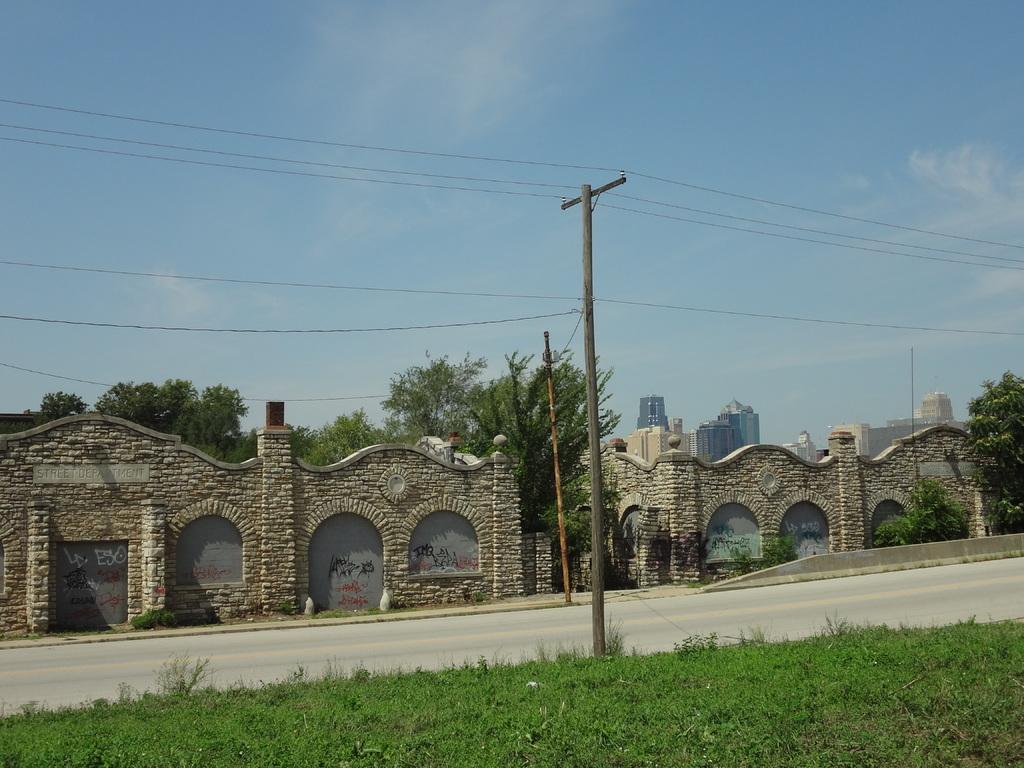In one or two sentences, can you explain what this image depicts? in this picture there is a pole in the center of the image and there is grass land at the bottom side of the image, there is a boundary and trees in the center of the image, there are buildings on the right side of the image. 